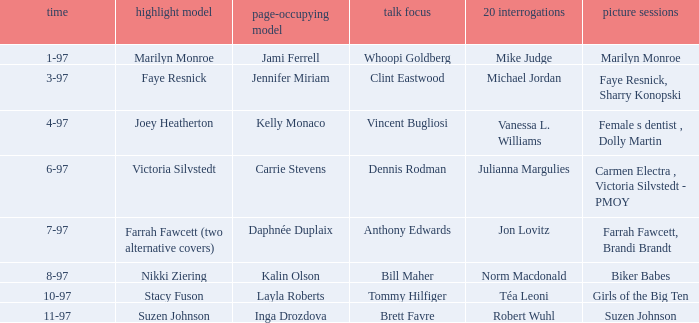What is the name of the cover model on 3-97? Faye Resnick. 